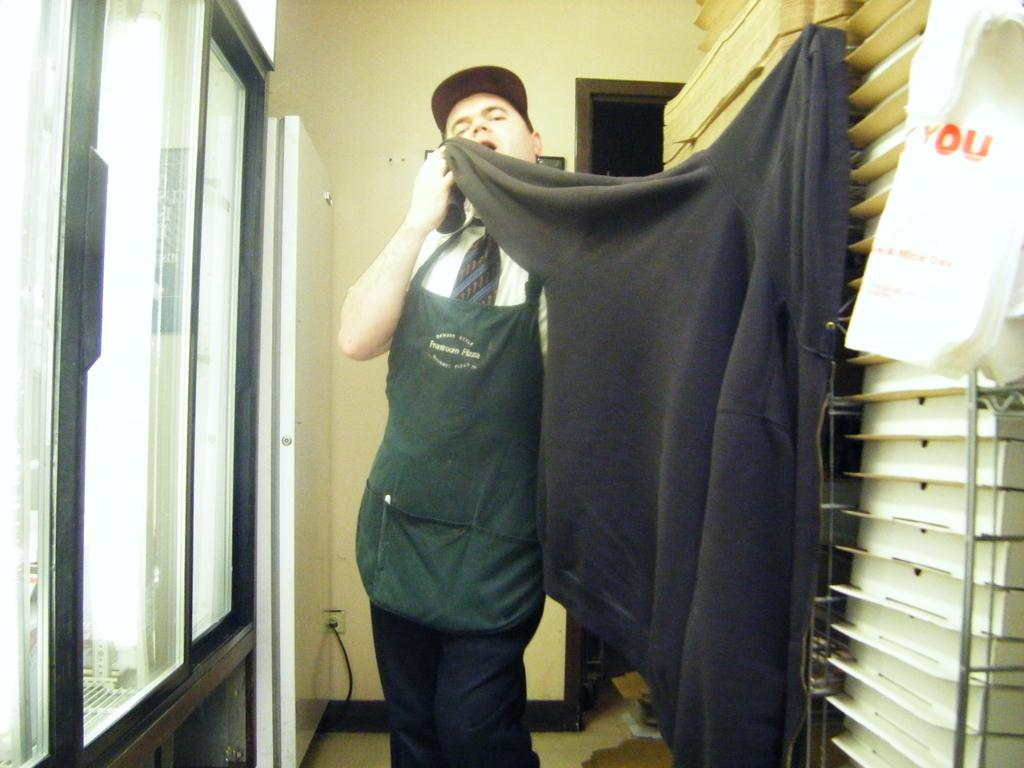Who is present in the image? There is a man in the image. What is the man wearing? The man is wearing an apron. What is the man doing in the image? The man is standing and holding a hoodie on the wall. What can be seen on the left side of the image? There is a glass window on the left side of the image. What type of collar is the man wearing in the image? The man is not wearing a collar in the image; he is wearing an apron. 